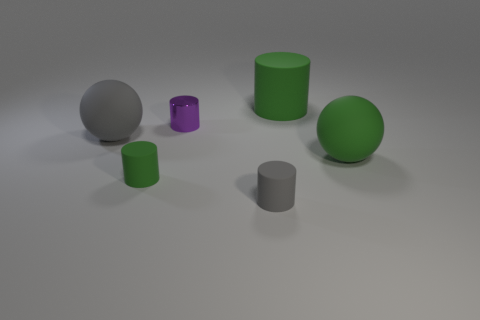Is the gray matte cylinder the same size as the purple object?
Provide a short and direct response. Yes. Are there any green rubber balls that are in front of the big rubber ball on the right side of the small gray matte cylinder?
Your answer should be very brief. No. There is another cylinder that is the same color as the large cylinder; what size is it?
Give a very brief answer. Small. What is the shape of the big green rubber thing that is in front of the large gray ball?
Give a very brief answer. Sphere. How many gray things are to the left of the tiny rubber cylinder in front of the green matte cylinder to the left of the gray cylinder?
Provide a short and direct response. 1. There is a metal cylinder; does it have the same size as the green matte cylinder behind the tiny green thing?
Keep it short and to the point. No. How big is the green matte cylinder in front of the large matte ball that is on the right side of the gray rubber sphere?
Ensure brevity in your answer.  Small. What number of green cylinders have the same material as the small green object?
Ensure brevity in your answer.  1. Are any purple metallic objects visible?
Offer a terse response. Yes. There is a green cylinder to the left of the metallic cylinder; how big is it?
Offer a terse response. Small. 